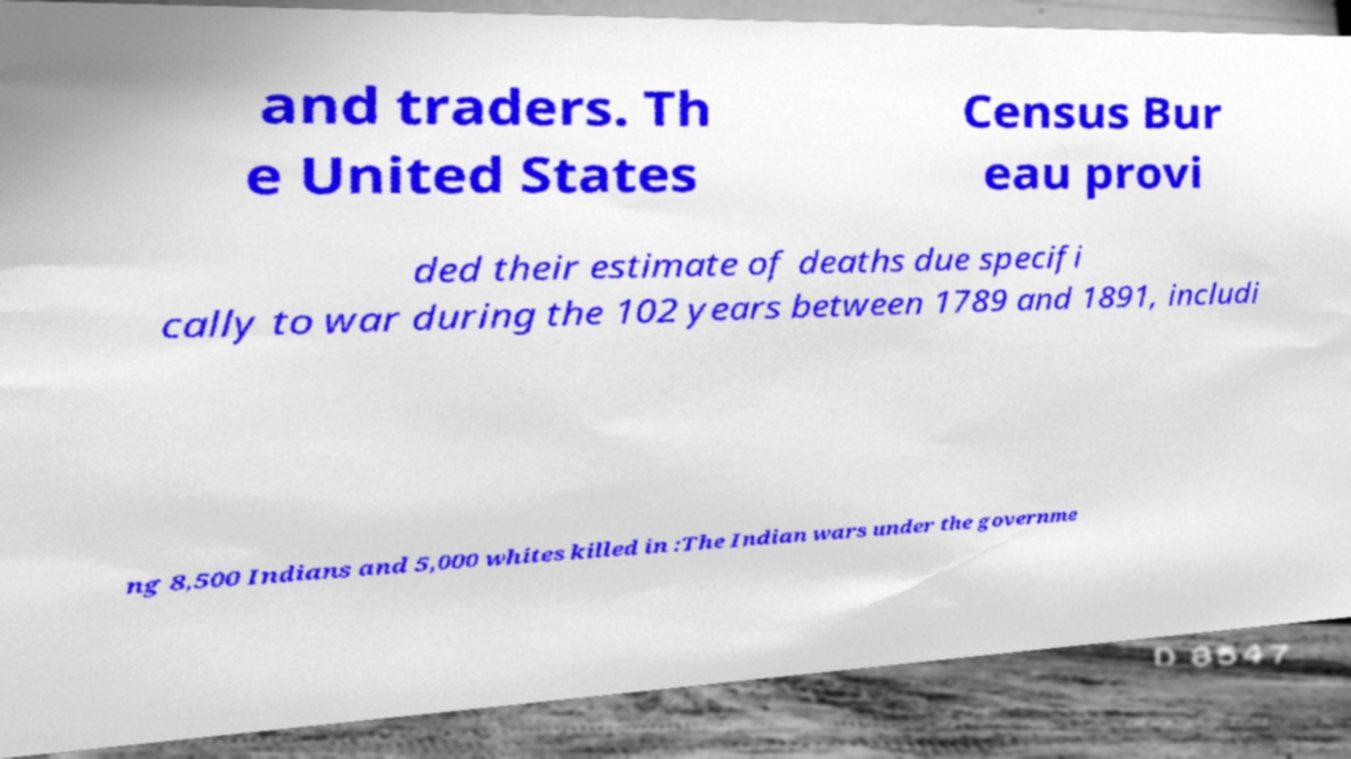For documentation purposes, I need the text within this image transcribed. Could you provide that? and traders. Th e United States Census Bur eau provi ded their estimate of deaths due specifi cally to war during the 102 years between 1789 and 1891, includi ng 8,500 Indians and 5,000 whites killed in :The Indian wars under the governme 